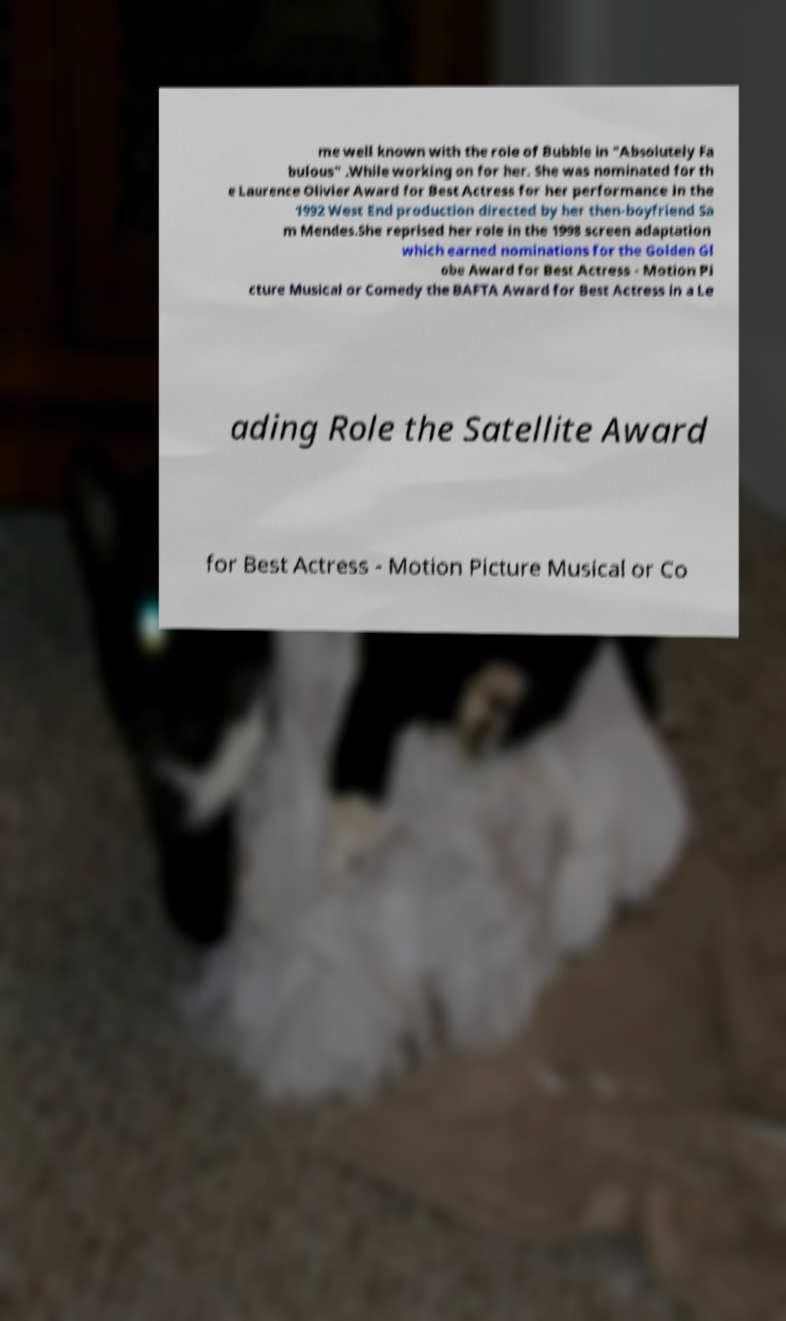Please read and relay the text visible in this image. What does it say? me well known with the role of Bubble in "Absolutely Fa bulous" .While working on for her. She was nominated for th e Laurence Olivier Award for Best Actress for her performance in the 1992 West End production directed by her then-boyfriend Sa m Mendes.She reprised her role in the 1998 screen adaptation which earned nominations for the Golden Gl obe Award for Best Actress - Motion Pi cture Musical or Comedy the BAFTA Award for Best Actress in a Le ading Role the Satellite Award for Best Actress - Motion Picture Musical or Co 